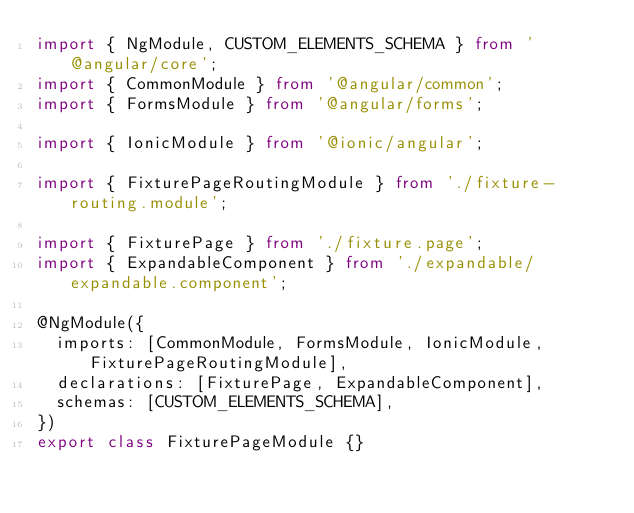<code> <loc_0><loc_0><loc_500><loc_500><_TypeScript_>import { NgModule, CUSTOM_ELEMENTS_SCHEMA } from '@angular/core';
import { CommonModule } from '@angular/common';
import { FormsModule } from '@angular/forms';

import { IonicModule } from '@ionic/angular';

import { FixturePageRoutingModule } from './fixture-routing.module';

import { FixturePage } from './fixture.page';
import { ExpandableComponent } from './expandable/expandable.component';

@NgModule({
  imports: [CommonModule, FormsModule, IonicModule, FixturePageRoutingModule],
  declarations: [FixturePage, ExpandableComponent],
  schemas: [CUSTOM_ELEMENTS_SCHEMA],
})
export class FixturePageModule {}
</code> 